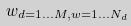Convert formula to latex. <formula><loc_0><loc_0><loc_500><loc_500>w _ { d = 1 \dots M , w = 1 \dots N _ { d } }</formula> 